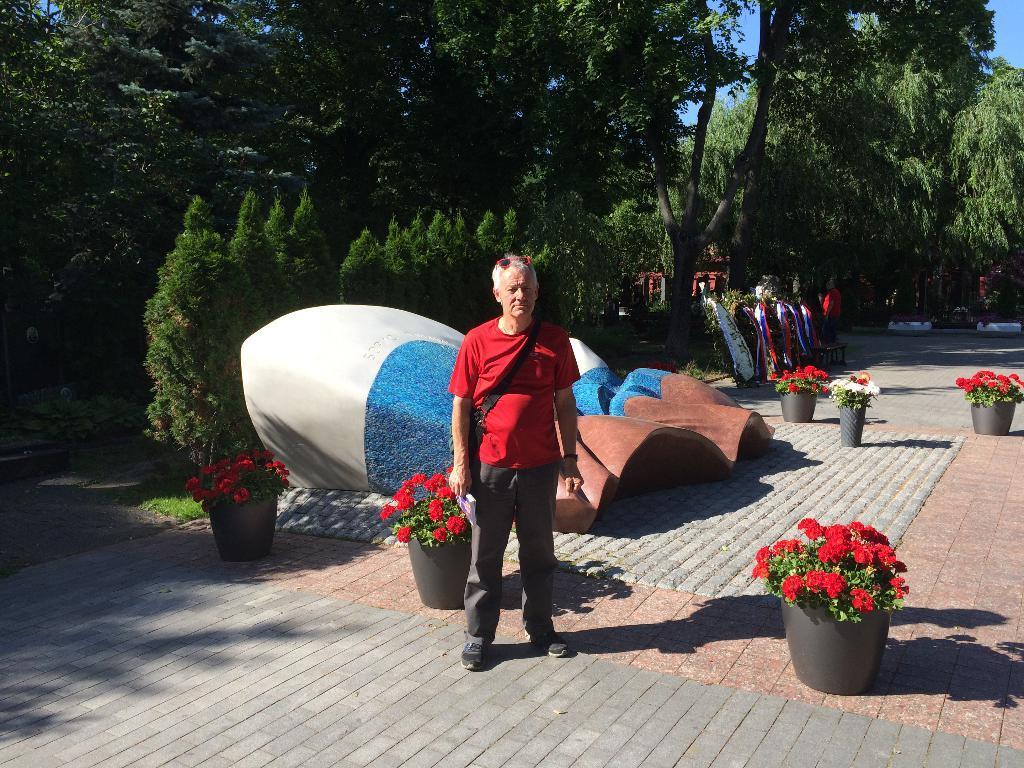How would you summarize this image in a sentence or two? In this image in the center there is one person who is standing and at the bottom there are some flower pots, plants, flowers and some boards, in the background there are a group of trees. 